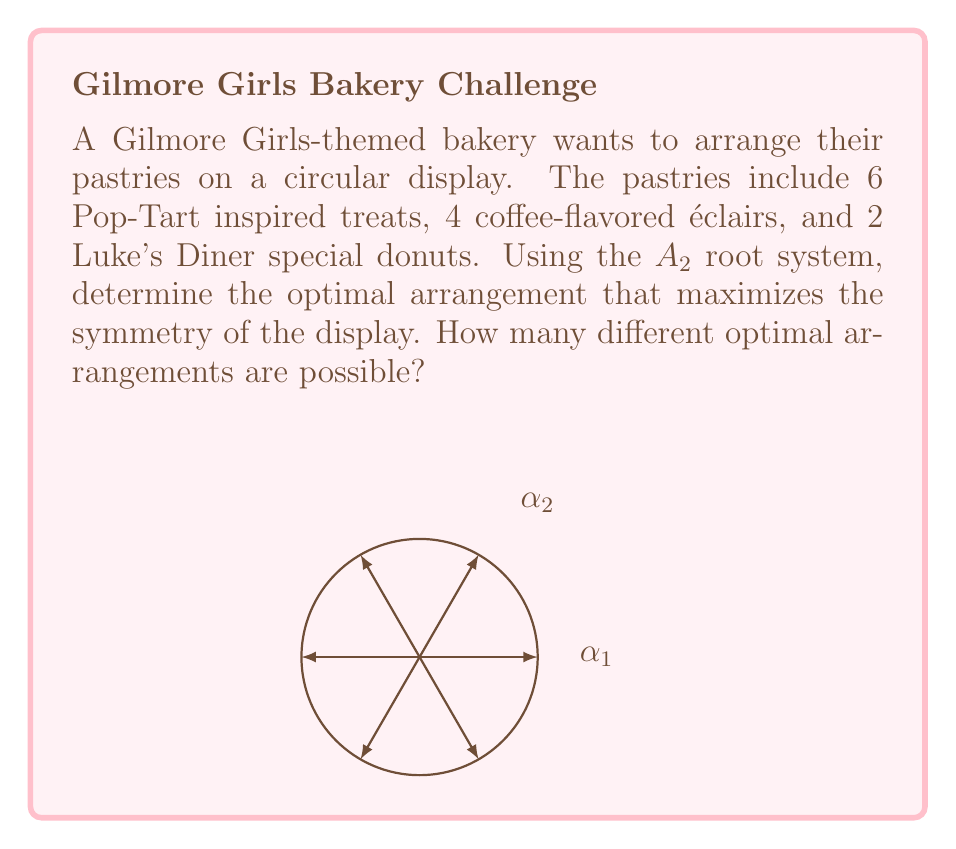Teach me how to tackle this problem. To solve this problem, we'll use the properties of the $A_2$ root system and apply them to our pastry arrangement:

1) The $A_2$ root system has 6 roots in total, forming a regular hexagon.

2) We have 12 pastries in total: 6 Pop-Tarts, 4 éclairs, and 2 donuts.

3) To maximize symmetry, we need to arrange the pastries so that they respect the symmetries of the $A_2$ root system.

4) The most symmetric arrangement would be to place the 6 Pop-Tarts at the vertices of the hexagon (corresponding to the 6 roots).

5) The 4 éclairs can be placed at alternating edges of the hexagon, leaving two opposite edges empty.

6) The 2 donuts can be placed at the center of these empty edges.

7) This arrangement respects the rotational symmetry of the $A_2$ root system.

8) To count the number of different optimal arrangements:
   - The Pop-Tarts can only be rotated as a whole (6 ways)
   - For each Pop-Tart arrangement, the éclairs and donuts can be placed in 3 ways (rotating by 60°)

9) Therefore, the total number of optimal arrangements is $6 \times 3 = 18$.

This arrangement maximizes symmetry by aligning the most numerous pastry (Pop-Tarts) with the roots of the $A_2$ system, and distributing the other pastries evenly in a way that preserves the sixfold rotational symmetry.
Answer: 18 optimal arrangements 